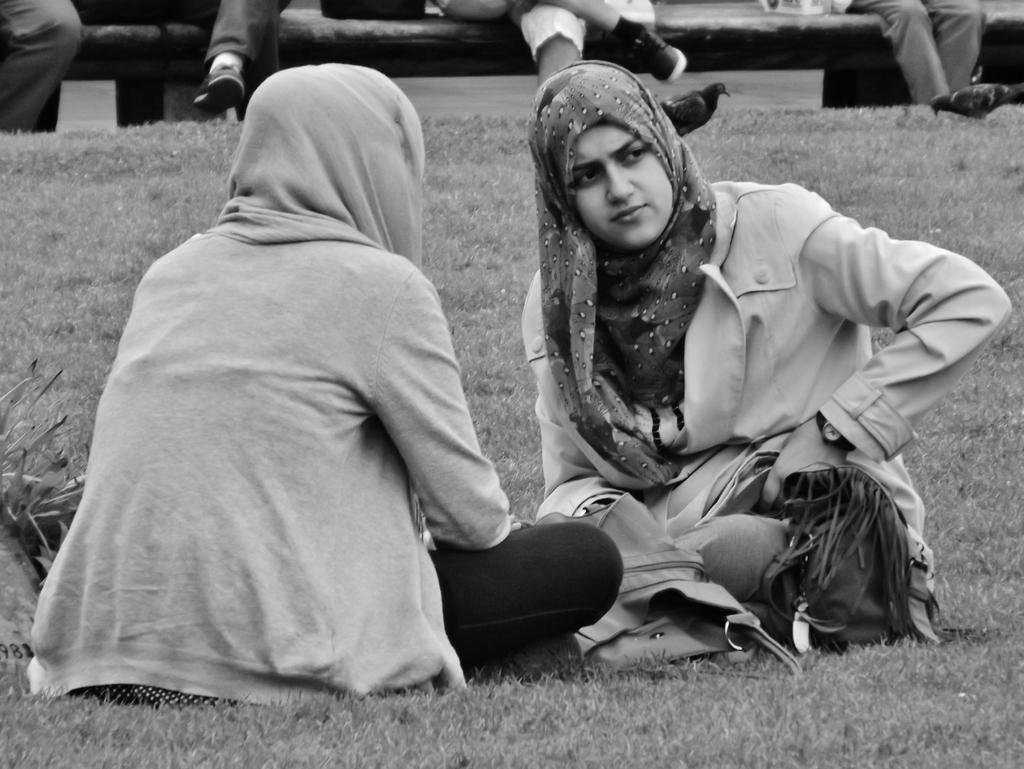How many women are in the image? There are two women in the image. What are the women doing in the image? The women are facing each other in the image. Where are the women sitting in the image? The women are sitting on the grass in the image. Can you describe the background of the image? In the background of the image, there are persons sitting on a bench. What shape is the mailbox in the image? There is no mailbox present in the image. 